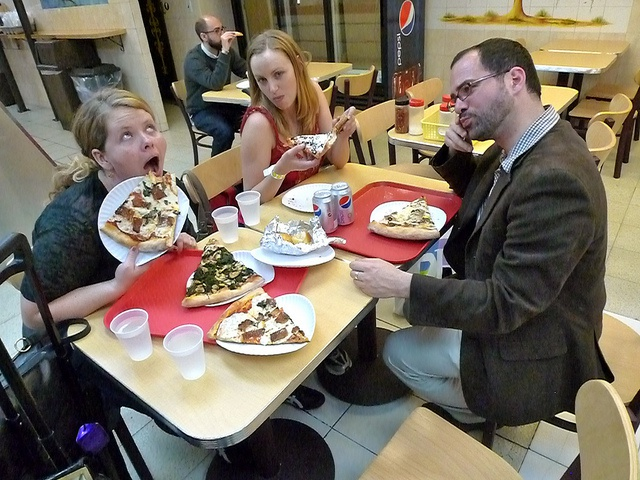Describe the objects in this image and their specific colors. I can see people in darkgray, black, and gray tones, dining table in darkgray, ivory, khaki, salmon, and tan tones, people in darkgray, black, and gray tones, people in darkgray, gray, tan, and maroon tones, and chair in darkgray, tan, and khaki tones in this image. 